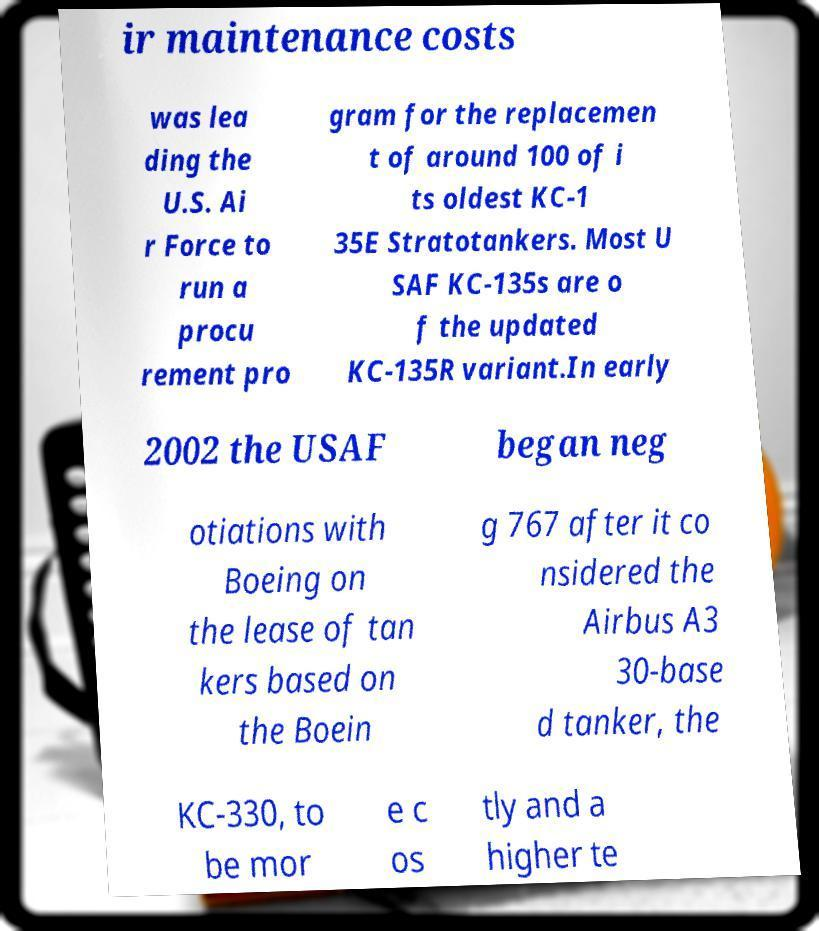Please read and relay the text visible in this image. What does it say? ir maintenance costs was lea ding the U.S. Ai r Force to run a procu rement pro gram for the replacemen t of around 100 of i ts oldest KC-1 35E Stratotankers. Most U SAF KC-135s are o f the updated KC-135R variant.In early 2002 the USAF began neg otiations with Boeing on the lease of tan kers based on the Boein g 767 after it co nsidered the Airbus A3 30-base d tanker, the KC-330, to be mor e c os tly and a higher te 